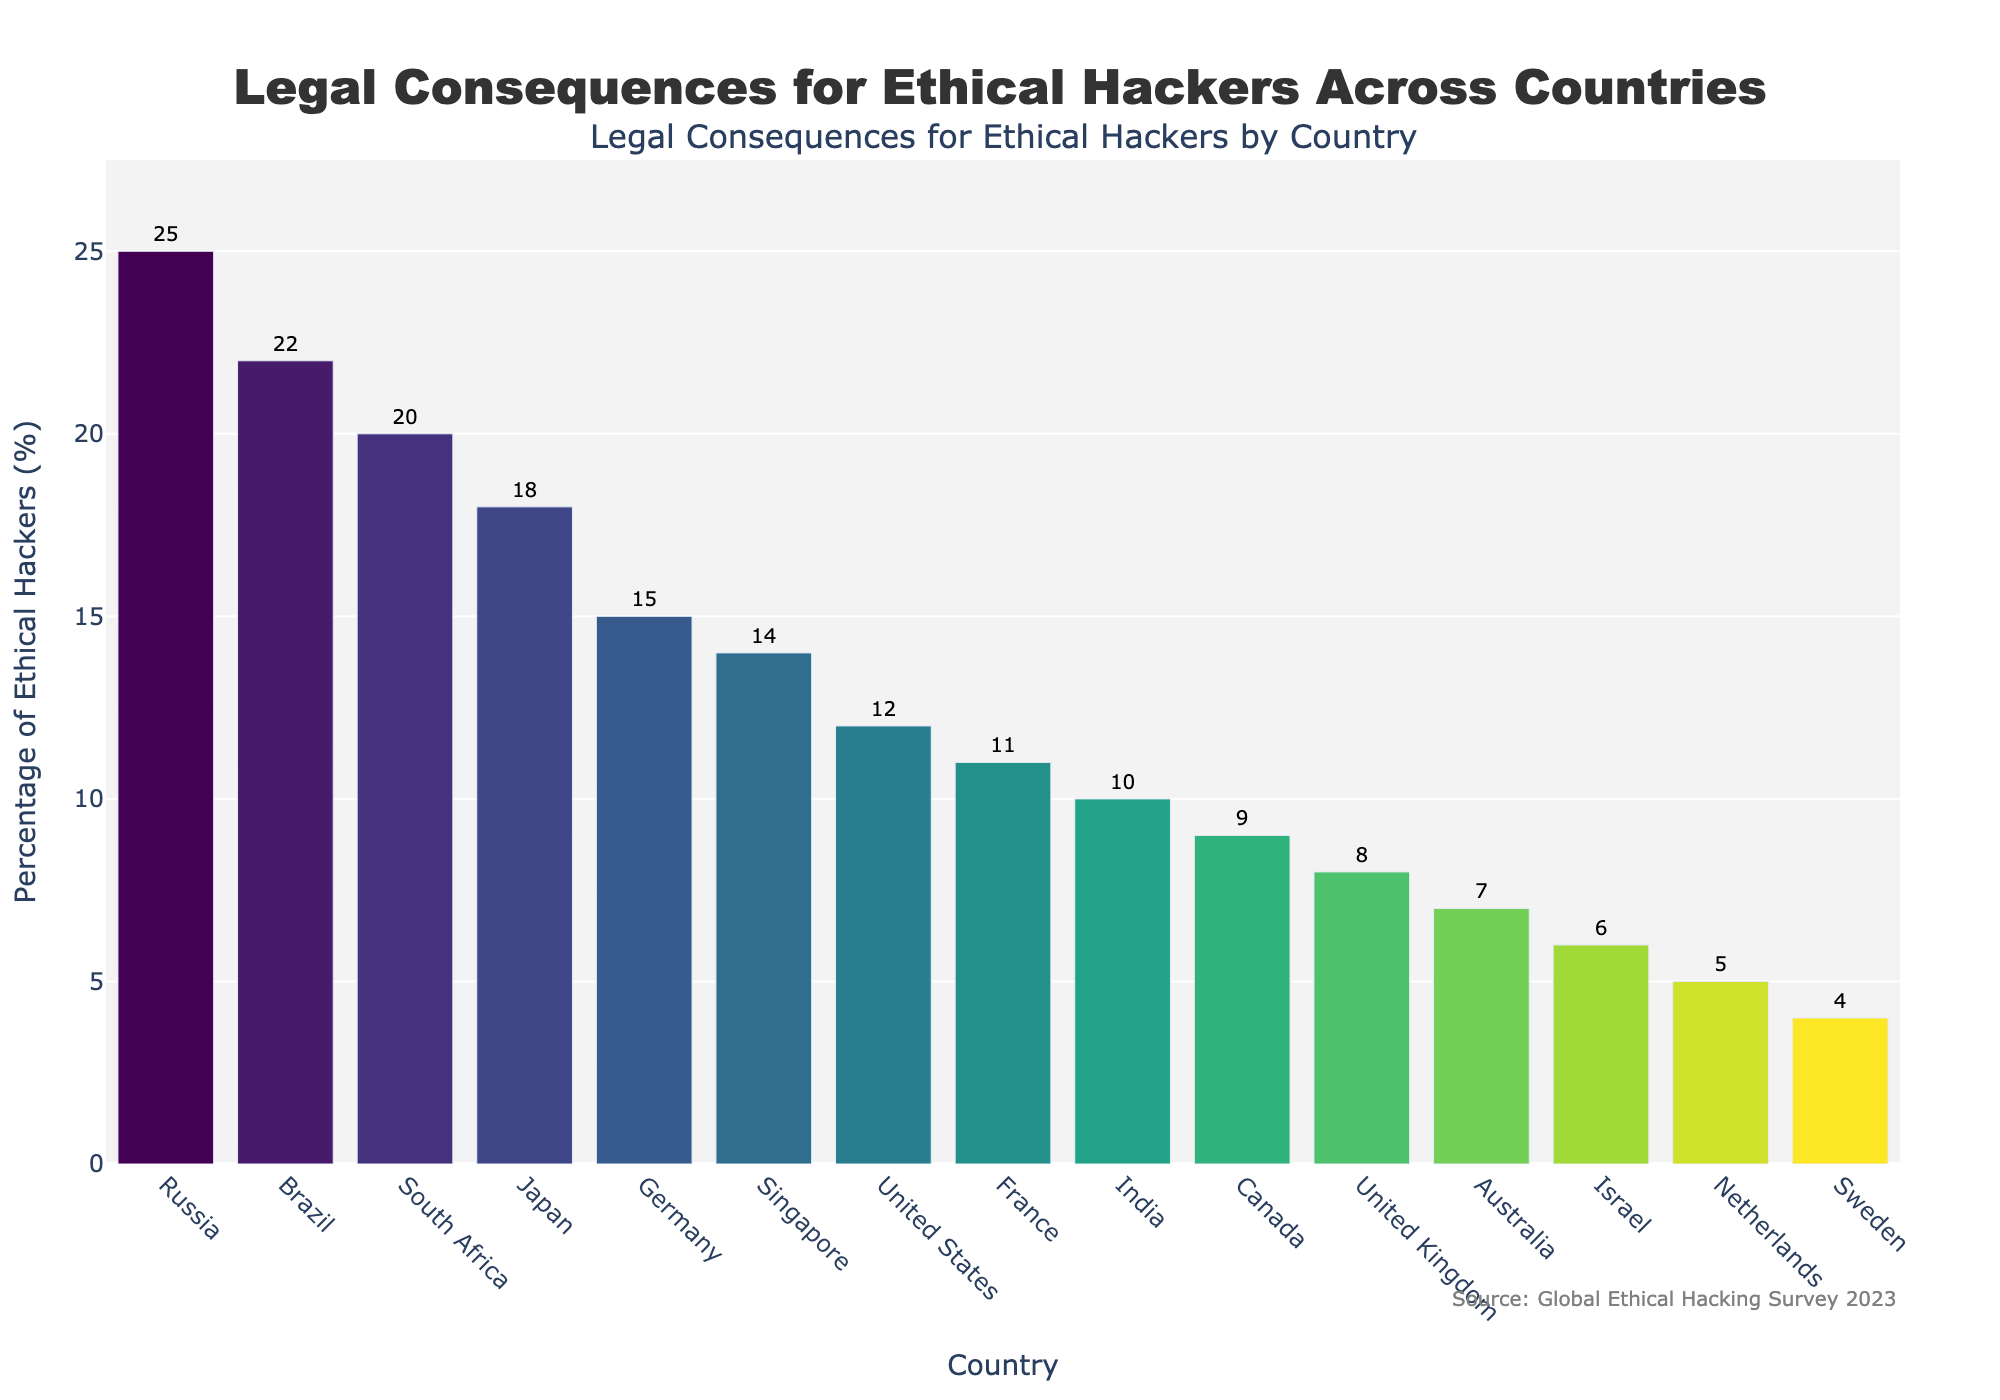Which country has the highest percentage of ethical hackers facing legal consequences? By observing the heights of the bars in the figure, the tallest bar represents Russia.
Answer: Russia Which country has the lowest percentage of ethical hackers facing legal consequences? By looking at the shortest bar in the figure, the lowest percentage is represented by Sweden.
Answer: Sweden What is the difference in percentage between Brazil and Australia? The percentage for Brazil is 22%, and for Australia, it is 7%. The difference is 22% - 7% = 15%.
Answer: 15% Are there more countries with percentages above or below 10%? Count the number of bars above and below the 10% mark. Above 10%, there are 8 countries (United States, Germany, Japan, Russia, India, Brazil, Singapore, South Africa). Below 10%, there are 7 countries (United Kingdom, Netherlands, Australia, Canada, France, Sweden, Israel). 8 > 7, so there are more countries above 10%.
Answer: Above 10% Which two countries have nearly the same percentages of ethical hackers facing legal consequences? By visually comparing the heights of the bars, Canada (9%) and the United Kingdom (8%) have nearly similar heights.
Answer: Canada and United Kingdom What is the average percentage of all the countries combined? Add the percentages of all countries and then divide by the number of countries (15). Sum = 12 + 8 + 15 + 5 + 18 + 25 + 10 + 22 + 7 + 9 + 11 + 4 + 6 + 14 + 20 = 186. So, the average is 186 / 15 = 12.4%.
Answer: 12.4% Which country has a higher percentage, Germany or Japan? Compare the heights of the bars for Germany (15%) and Japan (18%). Japan's bar is taller.
Answer: Japan What is the total percentage of ethical hackers facing legal consequences for the United States, United Kingdom, and Australia combined? Sum the percentages for these three countries: United States (12%), United Kingdom (8%), and Australia (7%). The total is 12% + 8% + 7% = 27%.
Answer: 27% What is the median value of the percentages? Sort the percentages and find the middle value in the sorted list. Sorted list: 4, 5, 6, 7, 8, 9, 10, 11, 12, 14, 15, 18, 20, 22, 25. The median is the 8th value, which is 11.
Answer: 11 